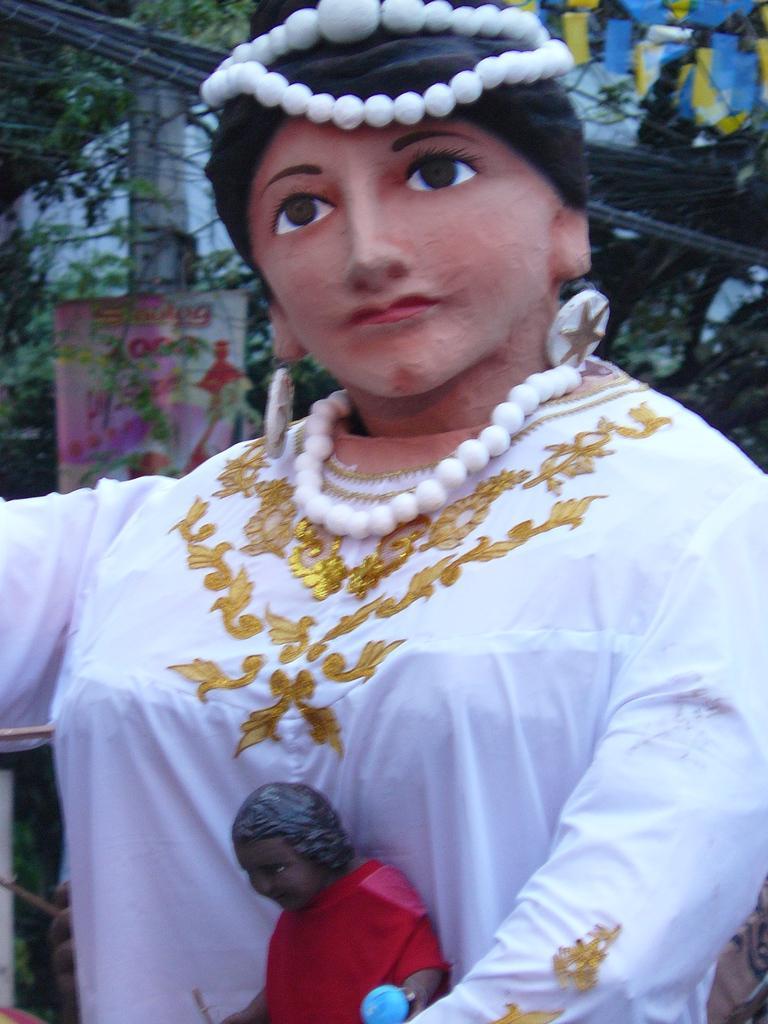Please provide a concise description of this image. In this picture we can see a statue, in the background we can find a pole, flexi and trees, and also we can see cables. 